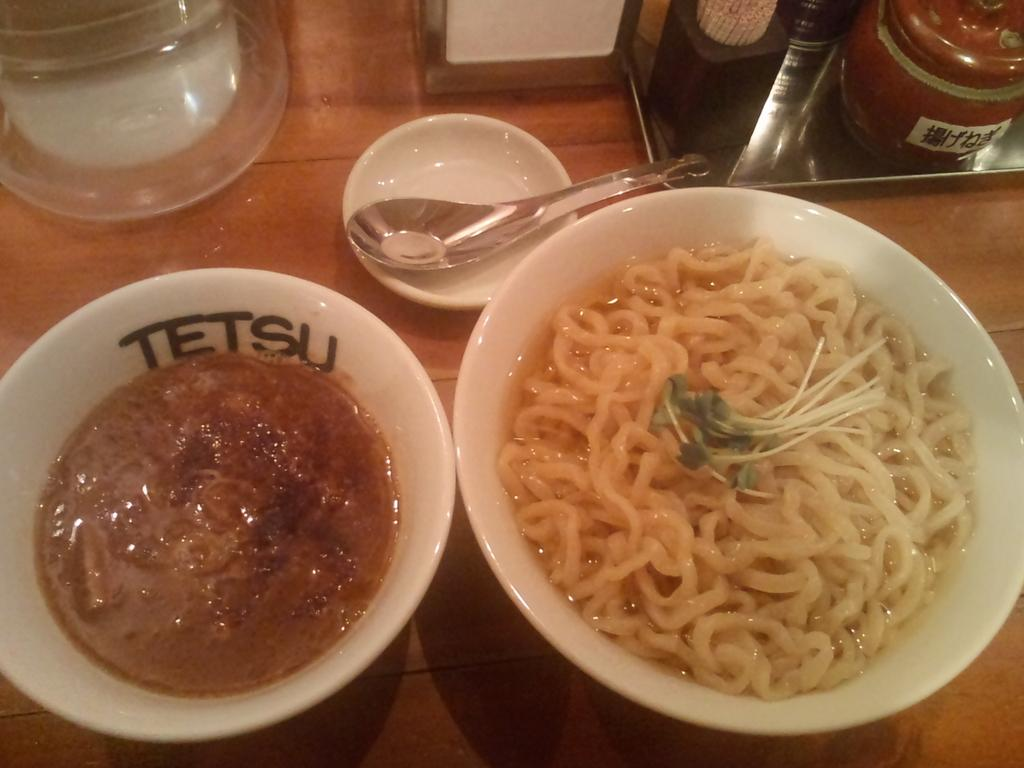What piece of furniture is present in the image? There is a table in the image. What is placed on the table? There are bowls, spoons, tissue papers, and other objects on the table. What can be found inside the bowls? There are food items in the bowls. What might be used for eating the food in the bowls? The spoons on the table can be used for eating the food. Are there any children playing with wooden toys on the table in the image? There is no mention of children or wooden toys in the image; it only shows a table with bowls, spoons, tissue papers, and other objects. 